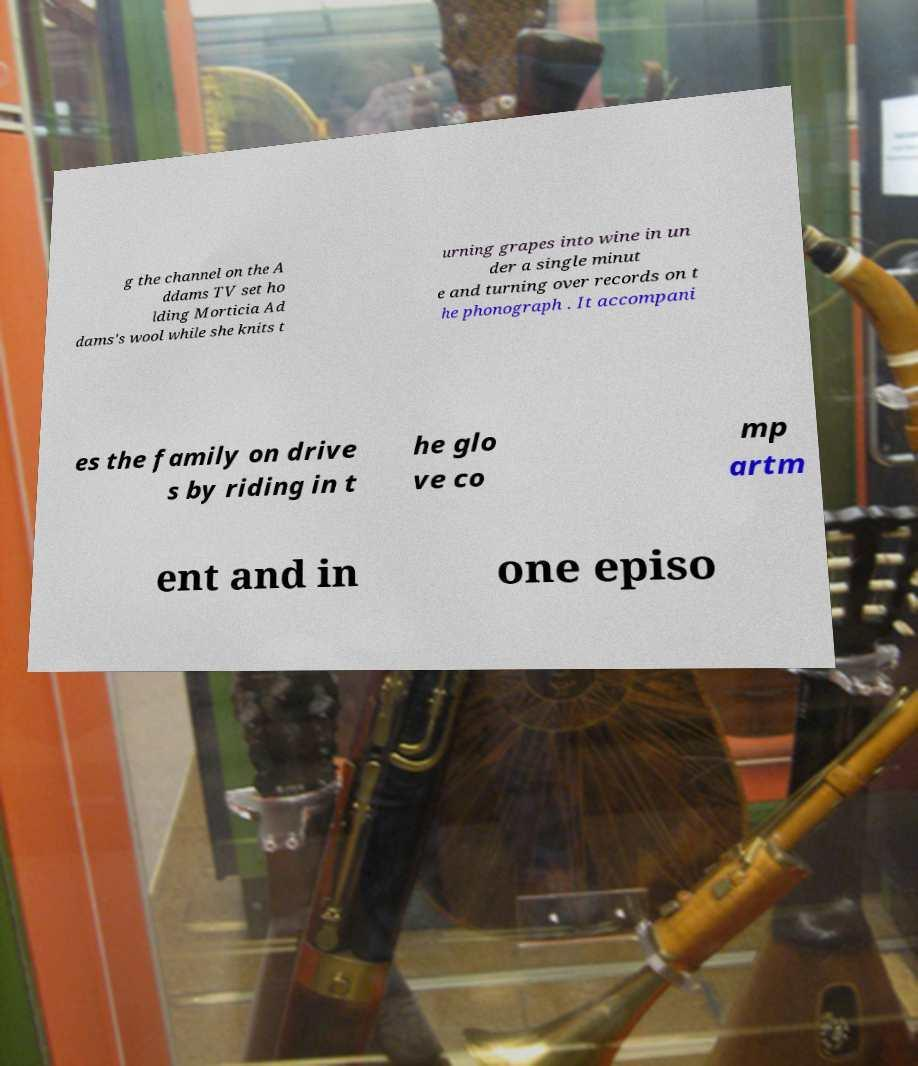What messages or text are displayed in this image? I need them in a readable, typed format. g the channel on the A ddams TV set ho lding Morticia Ad dams's wool while she knits t urning grapes into wine in un der a single minut e and turning over records on t he phonograph . It accompani es the family on drive s by riding in t he glo ve co mp artm ent and in one episo 